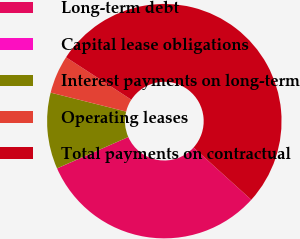Convert chart to OTSL. <chart><loc_0><loc_0><loc_500><loc_500><pie_chart><fcel>Long-term debt<fcel>Capital lease obligations<fcel>Interest payments on long-term<fcel>Operating leases<fcel>Total payments on contractual<nl><fcel>31.69%<fcel>0.01%<fcel>10.51%<fcel>5.26%<fcel>52.52%<nl></chart> 